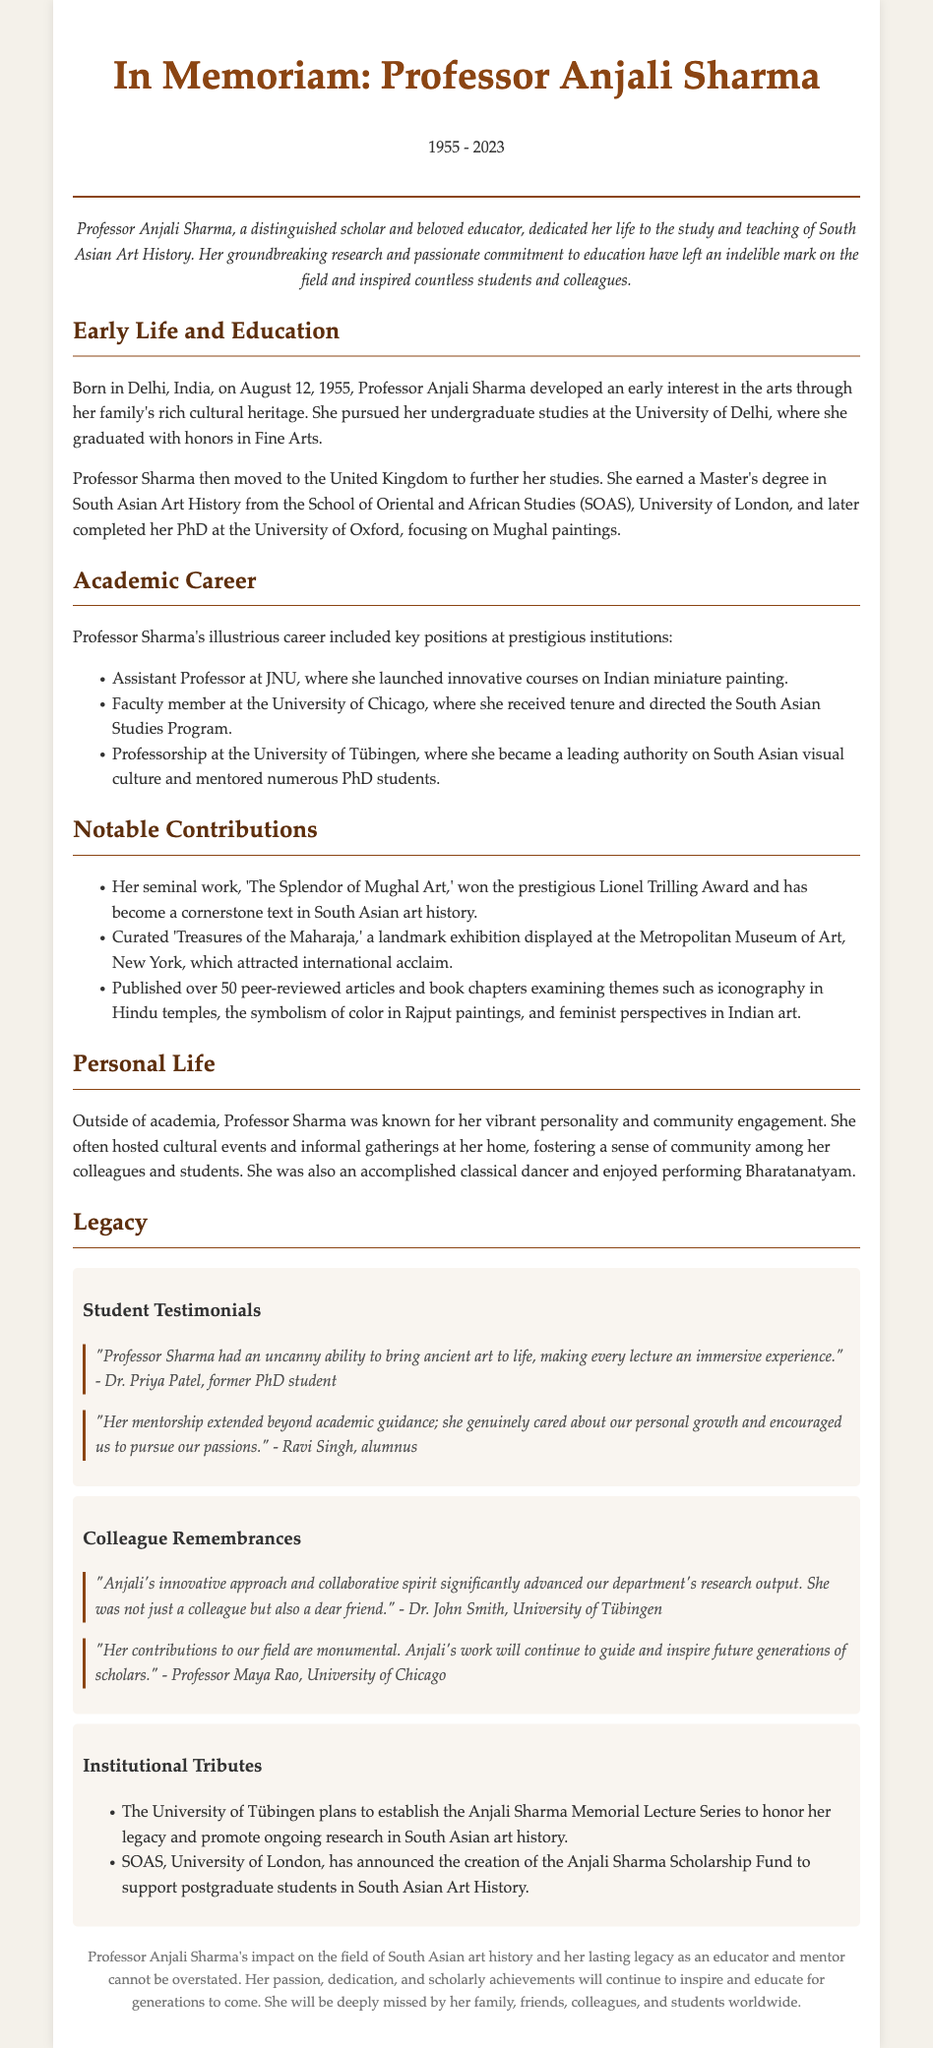what year was Professor Anjali Sharma born? The document states that Professor Anjali Sharma was born on August 12, 1955.
Answer: 1955 what significant award did her work, 'The Splendor of Mughal Art,' receive? The document mentions the prestigious Lionel Trilling Award for Professor Sharma's work.
Answer: Lionel Trilling Award which position did she hold at the University of Tübingen? The document specifies that she held a professorship at the University of Tübingen.
Answer: Professorship name one exhibition curated by Professor Sharma. The document lists 'Treasures of the Maharaja' as a landmark exhibition curated by her.
Answer: Treasures of the Maharaja what was the focus of Professor Sharma's PhD? The document indicates that her PhD focused on Mughal paintings.
Answer: Mughal paintings who is Dr. Priya Patel? The document quotes Dr. Priya Patel as a former PhD student providing a testimonial about Professor Sharma.
Answer: former PhD student what scholarship fund has been announced in memory of Professor Sharma? The document states the creation of the Anjali Sharma Scholarship Fund at SOAS, University of London.
Answer: Anjali Sharma Scholarship Fund how many peer-reviewed articles and book chapters did Professor Sharma publish? The document mentions that she published over 50 peer-reviewed articles and book chapters.
Answer: over 50 what type of events did Professor Sharma often host? According to the document, she often hosted cultural events and informal gatherings.
Answer: cultural events 